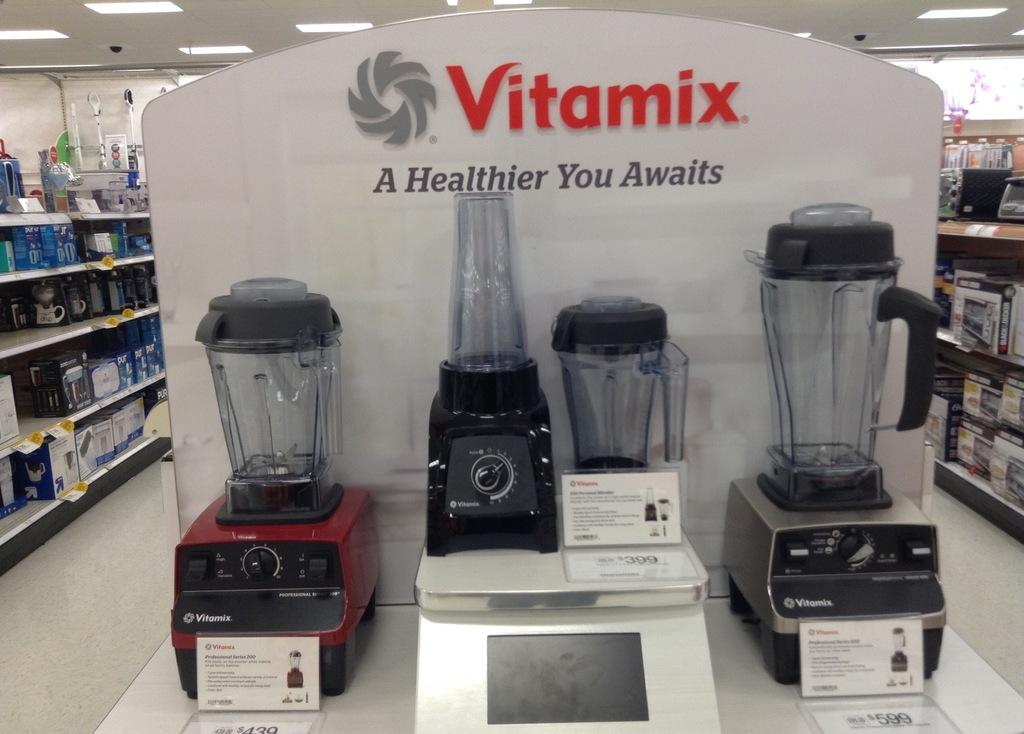<image>
Relay a brief, clear account of the picture shown. An advert for food blenders reading 'A Healthier You Awaits' 